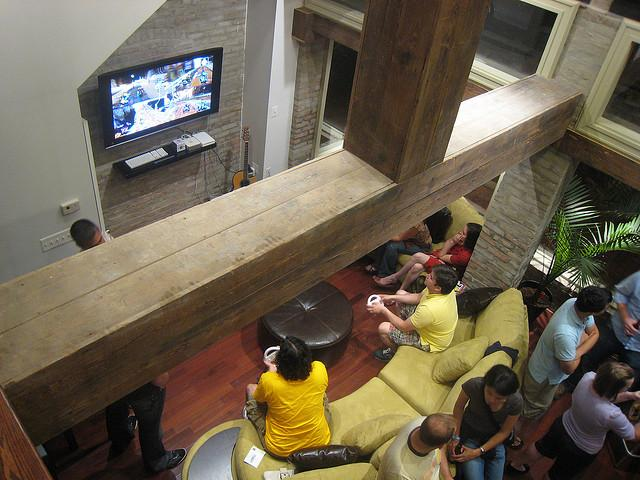The people sitting on the couch are competing in what on the television? video game 